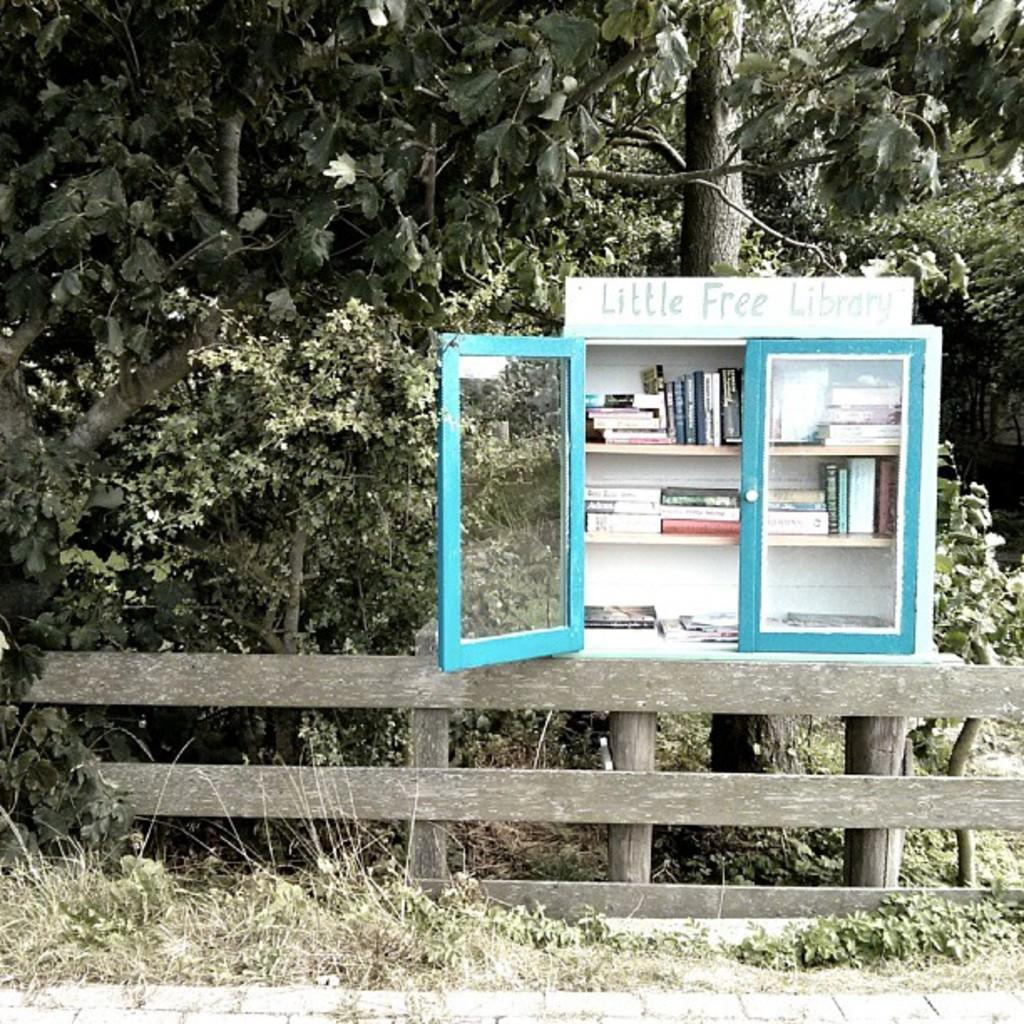<image>
Summarize the visual content of the image. A little free library sits with one door open near some trees. 